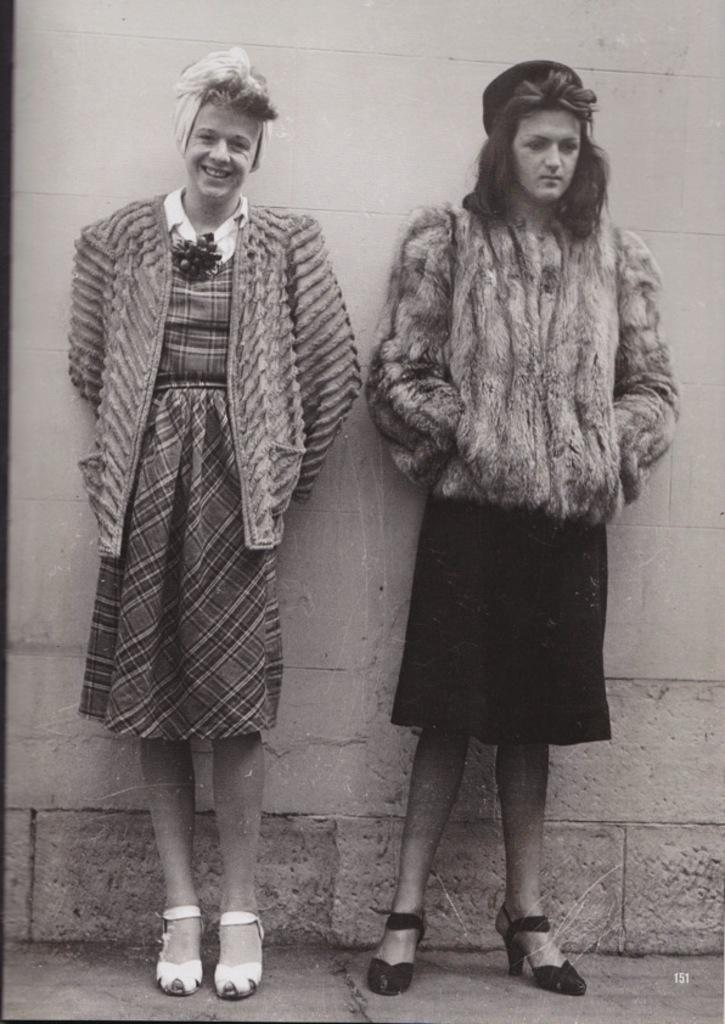How many people are in the image? There are two women in the image. What are the women doing in the image? The women are standing and smiling. What can be seen in the background of the image? There is a wall in the background of the image. What type of pencil is the woman on the right holding in the image? There is no pencil present in the image; both women are standing and smiling. 